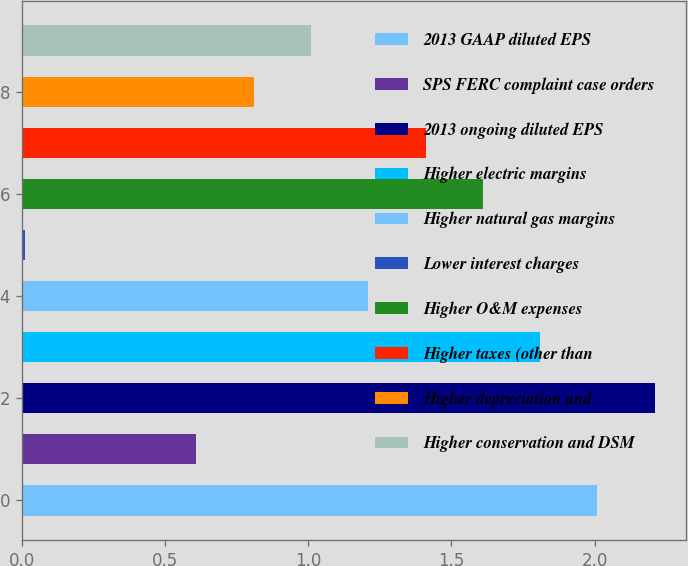Convert chart to OTSL. <chart><loc_0><loc_0><loc_500><loc_500><bar_chart><fcel>2013 GAAP diluted EPS<fcel>SPS FERC complaint case orders<fcel>2013 ongoing diluted EPS<fcel>Higher electric margins<fcel>Higher natural gas margins<fcel>Lower interest charges<fcel>Higher O&M expenses<fcel>Higher taxes (other than<fcel>Higher depreciation and<fcel>Higher conservation and DSM<nl><fcel>2.01<fcel>0.61<fcel>2.21<fcel>1.81<fcel>1.21<fcel>0.01<fcel>1.61<fcel>1.41<fcel>0.81<fcel>1.01<nl></chart> 